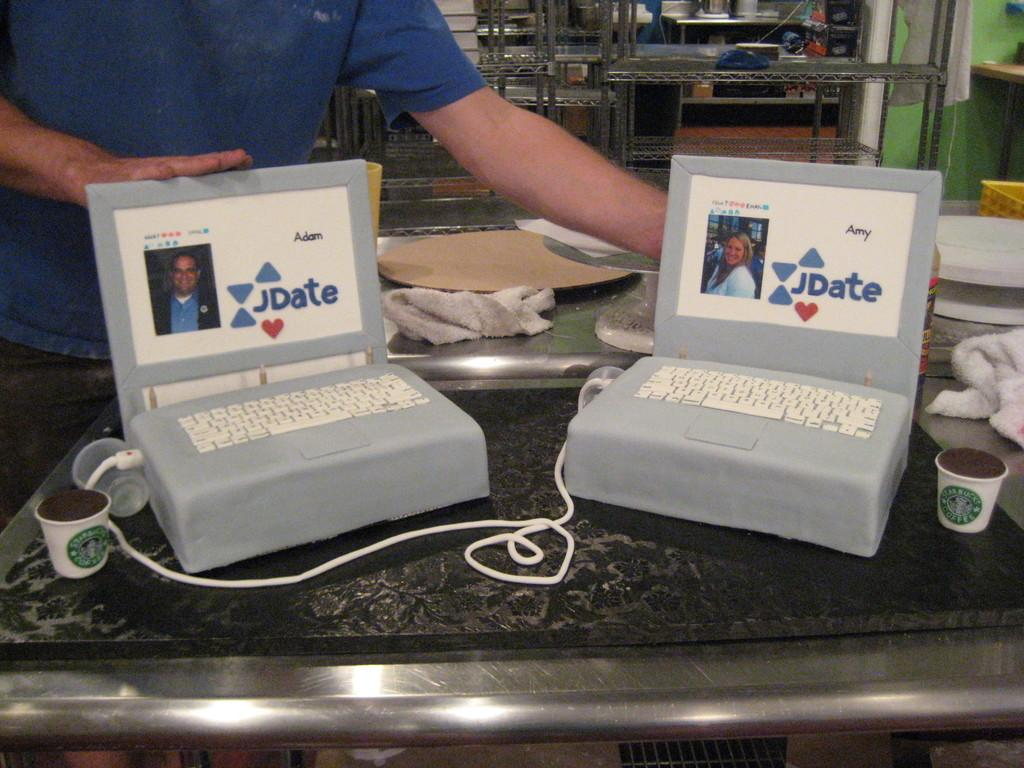What electronic devices can be seen in the image? There are laptops in the image. Can you describe the person in the image? A man is standing in the image. What type of container is visible in the image? There is a cup in the image. What is the purpose of the cable in the image? The cable is likely used to connect or power the laptops. What other type of container is present in the image? There is a bottle in the image. What material is present in the image that is not a container or electronic device? There is cloth present in the image. Where is the nest located in the image? There is no nest present in the image. What type of slave is depicted in the image? There is no depiction of a slave in the image; it features laptops, a man, a cup, a cable, a bottle, and cloth. 